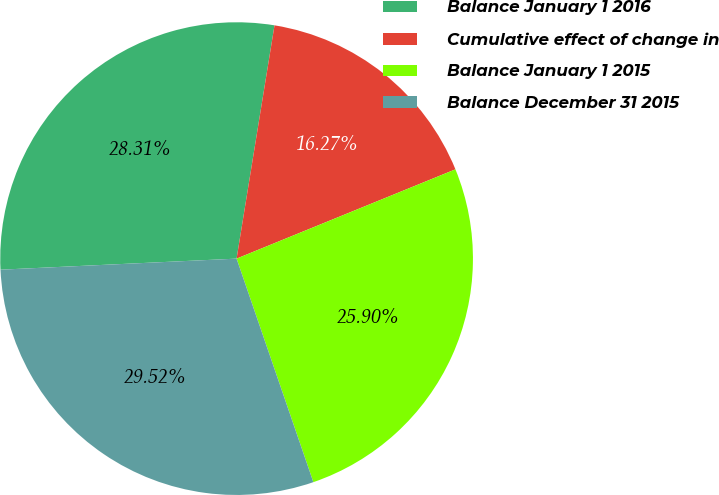Convert chart. <chart><loc_0><loc_0><loc_500><loc_500><pie_chart><fcel>Balance January 1 2016<fcel>Cumulative effect of change in<fcel>Balance January 1 2015<fcel>Balance December 31 2015<nl><fcel>28.31%<fcel>16.27%<fcel>25.9%<fcel>29.52%<nl></chart> 